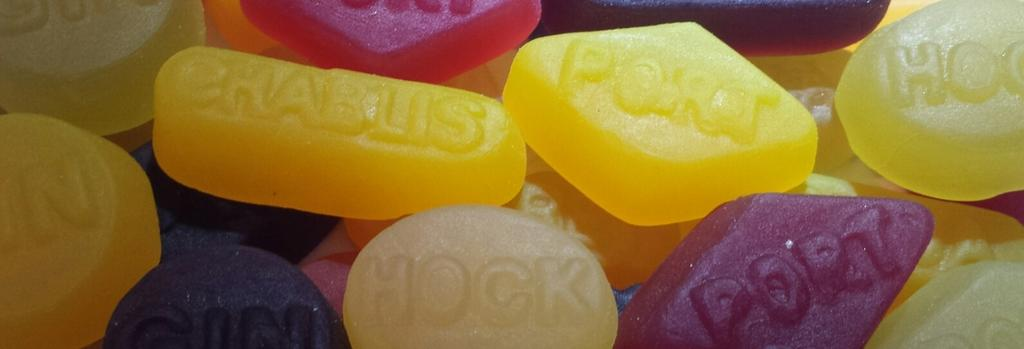What type of food items are present in the image? There are candies in the image. Can you describe the appearance of the candies? The candies have different colors. What additional feature can be observed on the candies? The candies have text on them. What type of board is being used to play a game with the candies in the image? There is no board or game present in the image; it only features candies with different colors and text. 